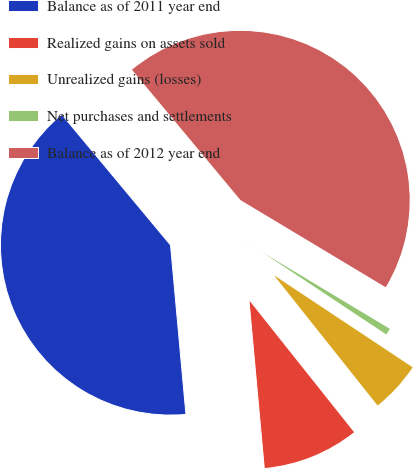Convert chart to OTSL. <chart><loc_0><loc_0><loc_500><loc_500><pie_chart><fcel>Balance as of 2011 year end<fcel>Realized gains on assets sold<fcel>Unrealized gains (losses)<fcel>Net purchases and settlements<fcel>Balance as of 2012 year end<nl><fcel>40.4%<fcel>9.25%<fcel>4.98%<fcel>0.72%<fcel>44.66%<nl></chart> 